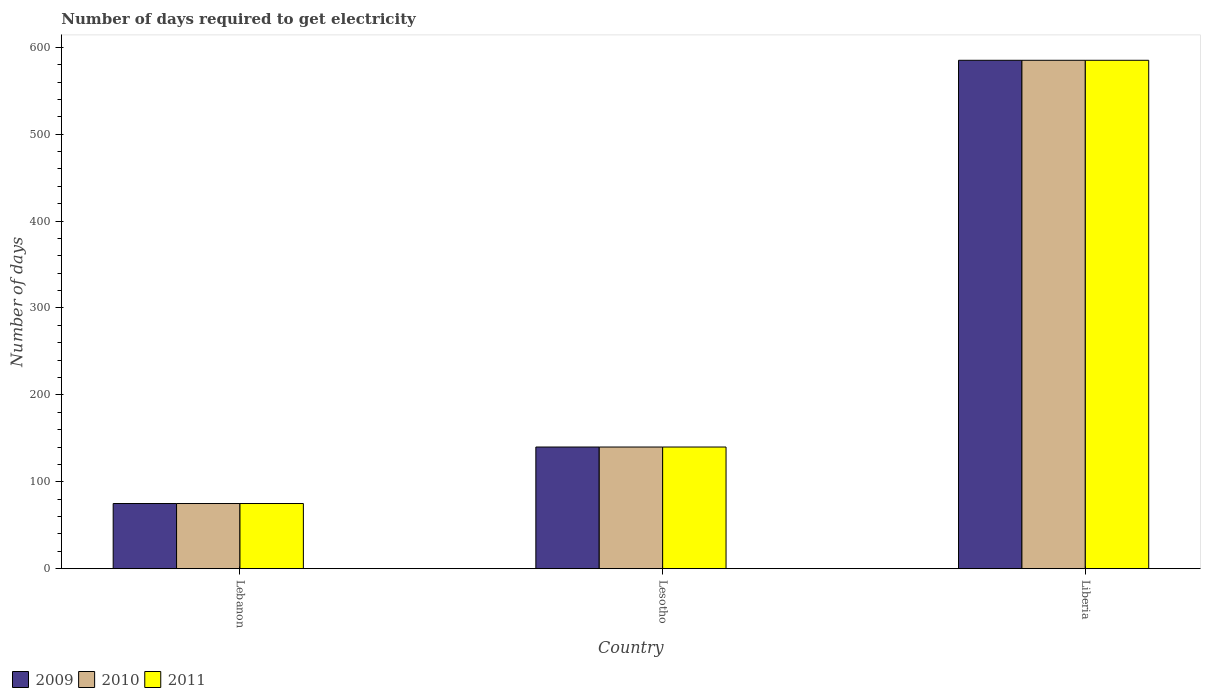How many groups of bars are there?
Ensure brevity in your answer.  3. Are the number of bars on each tick of the X-axis equal?
Ensure brevity in your answer.  Yes. How many bars are there on the 2nd tick from the right?
Give a very brief answer. 3. What is the label of the 3rd group of bars from the left?
Your response must be concise. Liberia. In how many cases, is the number of bars for a given country not equal to the number of legend labels?
Your answer should be compact. 0. What is the number of days required to get electricity in in 2009 in Liberia?
Offer a terse response. 585. Across all countries, what is the maximum number of days required to get electricity in in 2010?
Ensure brevity in your answer.  585. Across all countries, what is the minimum number of days required to get electricity in in 2010?
Give a very brief answer. 75. In which country was the number of days required to get electricity in in 2009 maximum?
Your answer should be compact. Liberia. In which country was the number of days required to get electricity in in 2011 minimum?
Your response must be concise. Lebanon. What is the total number of days required to get electricity in in 2009 in the graph?
Offer a terse response. 800. What is the difference between the number of days required to get electricity in in 2010 in Lebanon and that in Lesotho?
Provide a succinct answer. -65. What is the difference between the number of days required to get electricity in in 2009 in Lebanon and the number of days required to get electricity in in 2010 in Lesotho?
Your answer should be very brief. -65. What is the average number of days required to get electricity in in 2010 per country?
Your answer should be compact. 266.67. In how many countries, is the number of days required to get electricity in in 2009 greater than 440 days?
Provide a succinct answer. 1. What is the ratio of the number of days required to get electricity in in 2011 in Lesotho to that in Liberia?
Your answer should be compact. 0.24. Is the difference between the number of days required to get electricity in in 2011 in Lebanon and Lesotho greater than the difference between the number of days required to get electricity in in 2009 in Lebanon and Lesotho?
Make the answer very short. No. What is the difference between the highest and the second highest number of days required to get electricity in in 2009?
Keep it short and to the point. 510. What is the difference between the highest and the lowest number of days required to get electricity in in 2010?
Make the answer very short. 510. Is the sum of the number of days required to get electricity in in 2011 in Lebanon and Lesotho greater than the maximum number of days required to get electricity in in 2010 across all countries?
Offer a very short reply. No. What does the 1st bar from the right in Lebanon represents?
Your answer should be very brief. 2011. Is it the case that in every country, the sum of the number of days required to get electricity in in 2011 and number of days required to get electricity in in 2010 is greater than the number of days required to get electricity in in 2009?
Offer a very short reply. Yes. How many bars are there?
Provide a succinct answer. 9. Are all the bars in the graph horizontal?
Make the answer very short. No. Are the values on the major ticks of Y-axis written in scientific E-notation?
Offer a very short reply. No. Does the graph contain grids?
Provide a short and direct response. No. What is the title of the graph?
Ensure brevity in your answer.  Number of days required to get electricity. Does "1987" appear as one of the legend labels in the graph?
Keep it short and to the point. No. What is the label or title of the X-axis?
Keep it short and to the point. Country. What is the label or title of the Y-axis?
Offer a very short reply. Number of days. What is the Number of days in 2009 in Lebanon?
Your answer should be compact. 75. What is the Number of days in 2010 in Lebanon?
Offer a terse response. 75. What is the Number of days of 2011 in Lebanon?
Offer a terse response. 75. What is the Number of days in 2009 in Lesotho?
Give a very brief answer. 140. What is the Number of days in 2010 in Lesotho?
Make the answer very short. 140. What is the Number of days of 2011 in Lesotho?
Your answer should be compact. 140. What is the Number of days in 2009 in Liberia?
Offer a terse response. 585. What is the Number of days of 2010 in Liberia?
Give a very brief answer. 585. What is the Number of days in 2011 in Liberia?
Offer a very short reply. 585. Across all countries, what is the maximum Number of days of 2009?
Your answer should be very brief. 585. Across all countries, what is the maximum Number of days in 2010?
Provide a succinct answer. 585. Across all countries, what is the maximum Number of days of 2011?
Offer a very short reply. 585. Across all countries, what is the minimum Number of days of 2009?
Your answer should be compact. 75. Across all countries, what is the minimum Number of days of 2011?
Your answer should be compact. 75. What is the total Number of days of 2009 in the graph?
Give a very brief answer. 800. What is the total Number of days of 2010 in the graph?
Make the answer very short. 800. What is the total Number of days in 2011 in the graph?
Offer a very short reply. 800. What is the difference between the Number of days of 2009 in Lebanon and that in Lesotho?
Give a very brief answer. -65. What is the difference between the Number of days of 2010 in Lebanon and that in Lesotho?
Provide a short and direct response. -65. What is the difference between the Number of days of 2011 in Lebanon and that in Lesotho?
Your answer should be compact. -65. What is the difference between the Number of days in 2009 in Lebanon and that in Liberia?
Make the answer very short. -510. What is the difference between the Number of days of 2010 in Lebanon and that in Liberia?
Provide a succinct answer. -510. What is the difference between the Number of days of 2011 in Lebanon and that in Liberia?
Your response must be concise. -510. What is the difference between the Number of days in 2009 in Lesotho and that in Liberia?
Keep it short and to the point. -445. What is the difference between the Number of days of 2010 in Lesotho and that in Liberia?
Your answer should be very brief. -445. What is the difference between the Number of days in 2011 in Lesotho and that in Liberia?
Provide a short and direct response. -445. What is the difference between the Number of days in 2009 in Lebanon and the Number of days in 2010 in Lesotho?
Your answer should be very brief. -65. What is the difference between the Number of days of 2009 in Lebanon and the Number of days of 2011 in Lesotho?
Keep it short and to the point. -65. What is the difference between the Number of days in 2010 in Lebanon and the Number of days in 2011 in Lesotho?
Provide a short and direct response. -65. What is the difference between the Number of days of 2009 in Lebanon and the Number of days of 2010 in Liberia?
Give a very brief answer. -510. What is the difference between the Number of days of 2009 in Lebanon and the Number of days of 2011 in Liberia?
Provide a short and direct response. -510. What is the difference between the Number of days of 2010 in Lebanon and the Number of days of 2011 in Liberia?
Make the answer very short. -510. What is the difference between the Number of days in 2009 in Lesotho and the Number of days in 2010 in Liberia?
Your response must be concise. -445. What is the difference between the Number of days of 2009 in Lesotho and the Number of days of 2011 in Liberia?
Provide a succinct answer. -445. What is the difference between the Number of days of 2010 in Lesotho and the Number of days of 2011 in Liberia?
Offer a terse response. -445. What is the average Number of days in 2009 per country?
Offer a terse response. 266.67. What is the average Number of days of 2010 per country?
Give a very brief answer. 266.67. What is the average Number of days in 2011 per country?
Make the answer very short. 266.67. What is the difference between the Number of days of 2009 and Number of days of 2011 in Lebanon?
Give a very brief answer. 0. What is the difference between the Number of days in 2010 and Number of days in 2011 in Lebanon?
Provide a succinct answer. 0. What is the difference between the Number of days of 2009 and Number of days of 2011 in Liberia?
Give a very brief answer. 0. What is the difference between the Number of days of 2010 and Number of days of 2011 in Liberia?
Provide a succinct answer. 0. What is the ratio of the Number of days in 2009 in Lebanon to that in Lesotho?
Your response must be concise. 0.54. What is the ratio of the Number of days in 2010 in Lebanon to that in Lesotho?
Your answer should be very brief. 0.54. What is the ratio of the Number of days in 2011 in Lebanon to that in Lesotho?
Offer a very short reply. 0.54. What is the ratio of the Number of days in 2009 in Lebanon to that in Liberia?
Ensure brevity in your answer.  0.13. What is the ratio of the Number of days of 2010 in Lebanon to that in Liberia?
Offer a very short reply. 0.13. What is the ratio of the Number of days of 2011 in Lebanon to that in Liberia?
Your answer should be very brief. 0.13. What is the ratio of the Number of days of 2009 in Lesotho to that in Liberia?
Provide a succinct answer. 0.24. What is the ratio of the Number of days of 2010 in Lesotho to that in Liberia?
Offer a very short reply. 0.24. What is the ratio of the Number of days of 2011 in Lesotho to that in Liberia?
Ensure brevity in your answer.  0.24. What is the difference between the highest and the second highest Number of days of 2009?
Ensure brevity in your answer.  445. What is the difference between the highest and the second highest Number of days in 2010?
Ensure brevity in your answer.  445. What is the difference between the highest and the second highest Number of days of 2011?
Your answer should be compact. 445. What is the difference between the highest and the lowest Number of days of 2009?
Offer a very short reply. 510. What is the difference between the highest and the lowest Number of days in 2010?
Your response must be concise. 510. What is the difference between the highest and the lowest Number of days of 2011?
Keep it short and to the point. 510. 